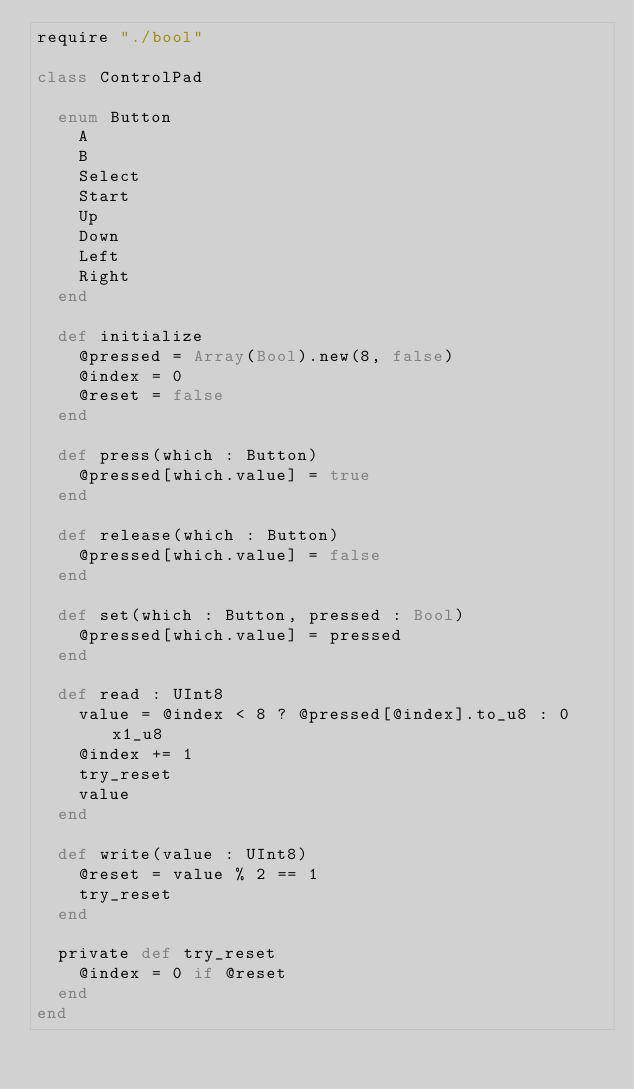Convert code to text. <code><loc_0><loc_0><loc_500><loc_500><_Crystal_>require "./bool"

class ControlPad

  enum Button
    A
    B
    Select
    Start
    Up
    Down
    Left
    Right
  end

  def initialize
    @pressed = Array(Bool).new(8, false)
    @index = 0
    @reset = false
  end

  def press(which : Button)
    @pressed[which.value] = true
  end

  def release(which : Button)
    @pressed[which.value] = false
  end

  def set(which : Button, pressed : Bool)
    @pressed[which.value] = pressed
  end

  def read : UInt8
    value = @index < 8 ? @pressed[@index].to_u8 : 0x1_u8
    @index += 1
    try_reset
    value
  end

  def write(value : UInt8)
    @reset = value % 2 == 1
    try_reset
  end

  private def try_reset
    @index = 0 if @reset
  end
end
</code> 